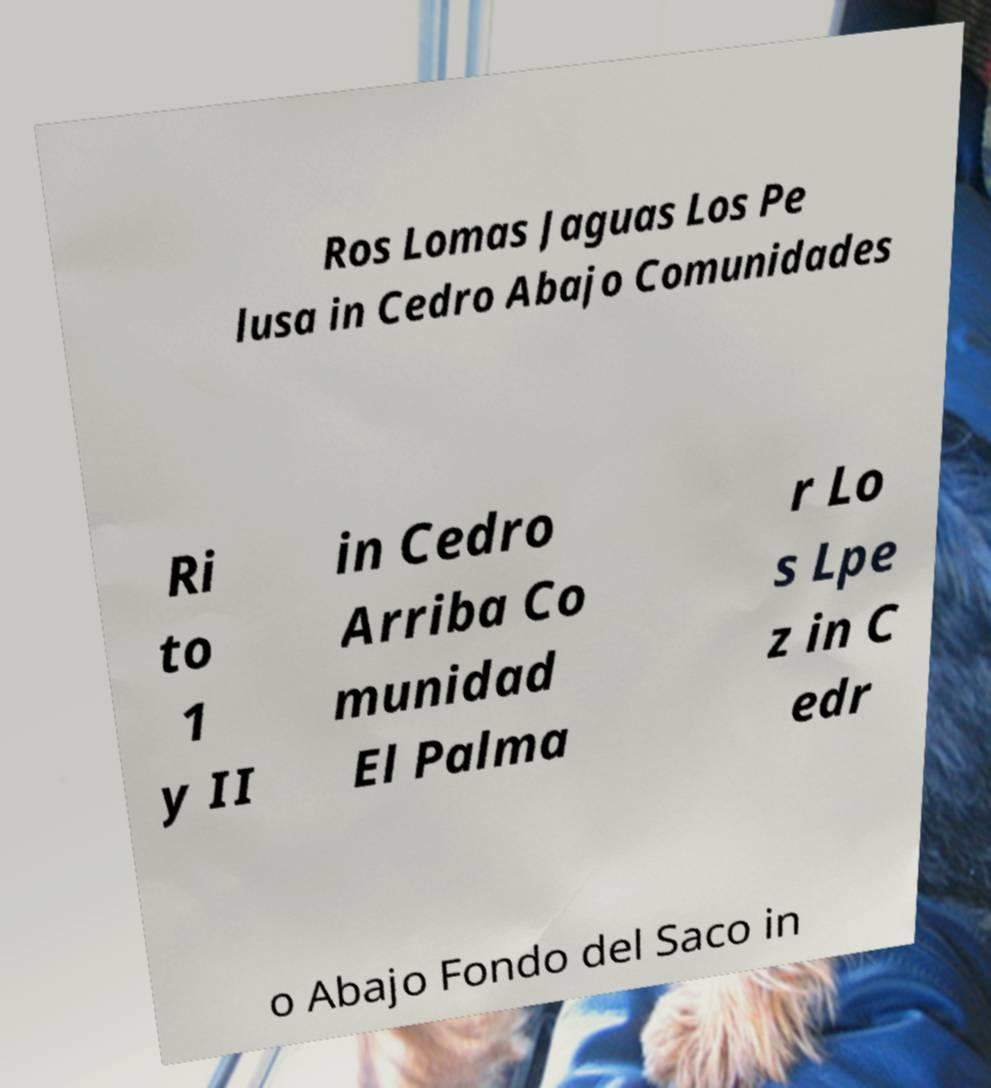What messages or text are displayed in this image? I need them in a readable, typed format. Ros Lomas Jaguas Los Pe lusa in Cedro Abajo Comunidades Ri to 1 y II in Cedro Arriba Co munidad El Palma r Lo s Lpe z in C edr o Abajo Fondo del Saco in 